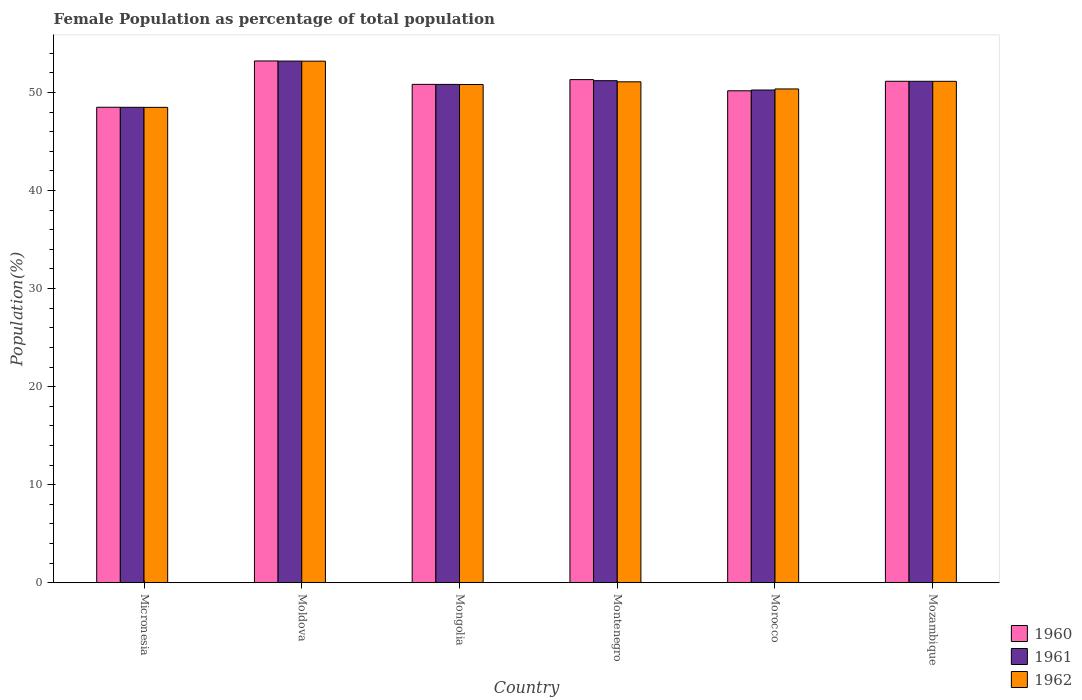How many groups of bars are there?
Give a very brief answer. 6. How many bars are there on the 5th tick from the left?
Give a very brief answer. 3. What is the label of the 6th group of bars from the left?
Make the answer very short. Mozambique. In how many cases, is the number of bars for a given country not equal to the number of legend labels?
Give a very brief answer. 0. What is the female population in in 1961 in Moldova?
Make the answer very short. 53.2. Across all countries, what is the maximum female population in in 1961?
Ensure brevity in your answer.  53.2. Across all countries, what is the minimum female population in in 1960?
Your response must be concise. 48.49. In which country was the female population in in 1961 maximum?
Your answer should be compact. Moldova. In which country was the female population in in 1960 minimum?
Offer a very short reply. Micronesia. What is the total female population in in 1962 in the graph?
Make the answer very short. 305.08. What is the difference between the female population in in 1962 in Mongolia and that in Morocco?
Provide a short and direct response. 0.45. What is the difference between the female population in in 1960 in Moldova and the female population in in 1962 in Mongolia?
Offer a very short reply. 2.4. What is the average female population in in 1960 per country?
Provide a succinct answer. 50.86. What is the difference between the female population in of/in 1960 and female population in of/in 1961 in Mozambique?
Make the answer very short. 0. In how many countries, is the female population in in 1962 greater than 24 %?
Provide a succinct answer. 6. What is the ratio of the female population in in 1962 in Micronesia to that in Montenegro?
Make the answer very short. 0.95. Is the female population in in 1960 in Micronesia less than that in Mongolia?
Your response must be concise. Yes. What is the difference between the highest and the second highest female population in in 1961?
Ensure brevity in your answer.  -0.06. What is the difference between the highest and the lowest female population in in 1960?
Offer a very short reply. 4.72. Is the sum of the female population in in 1962 in Mongolia and Montenegro greater than the maximum female population in in 1961 across all countries?
Offer a very short reply. Yes. How many bars are there?
Offer a very short reply. 18. Are all the bars in the graph horizontal?
Provide a short and direct response. No. How many countries are there in the graph?
Your response must be concise. 6. What is the difference between two consecutive major ticks on the Y-axis?
Ensure brevity in your answer.  10. Does the graph contain grids?
Give a very brief answer. No. Where does the legend appear in the graph?
Ensure brevity in your answer.  Bottom right. How many legend labels are there?
Offer a very short reply. 3. What is the title of the graph?
Give a very brief answer. Female Population as percentage of total population. Does "2013" appear as one of the legend labels in the graph?
Your response must be concise. No. What is the label or title of the X-axis?
Ensure brevity in your answer.  Country. What is the label or title of the Y-axis?
Provide a short and direct response. Population(%). What is the Population(%) of 1960 in Micronesia?
Your answer should be compact. 48.49. What is the Population(%) in 1961 in Micronesia?
Give a very brief answer. 48.49. What is the Population(%) in 1962 in Micronesia?
Provide a succinct answer. 48.48. What is the Population(%) of 1960 in Moldova?
Make the answer very short. 53.21. What is the Population(%) of 1961 in Moldova?
Your answer should be very brief. 53.2. What is the Population(%) in 1962 in Moldova?
Provide a succinct answer. 53.19. What is the Population(%) in 1960 in Mongolia?
Provide a succinct answer. 50.83. What is the Population(%) of 1961 in Mongolia?
Your answer should be very brief. 50.82. What is the Population(%) of 1962 in Mongolia?
Provide a succinct answer. 50.82. What is the Population(%) in 1960 in Montenegro?
Provide a short and direct response. 51.31. What is the Population(%) of 1961 in Montenegro?
Give a very brief answer. 51.2. What is the Population(%) of 1962 in Montenegro?
Keep it short and to the point. 51.09. What is the Population(%) of 1960 in Morocco?
Provide a succinct answer. 50.17. What is the Population(%) of 1961 in Morocco?
Keep it short and to the point. 50.25. What is the Population(%) of 1962 in Morocco?
Your answer should be compact. 50.36. What is the Population(%) of 1960 in Mozambique?
Offer a terse response. 51.14. What is the Population(%) of 1961 in Mozambique?
Your answer should be very brief. 51.14. What is the Population(%) of 1962 in Mozambique?
Keep it short and to the point. 51.14. Across all countries, what is the maximum Population(%) in 1960?
Make the answer very short. 53.21. Across all countries, what is the maximum Population(%) of 1961?
Provide a succinct answer. 53.2. Across all countries, what is the maximum Population(%) of 1962?
Your answer should be compact. 53.19. Across all countries, what is the minimum Population(%) in 1960?
Your answer should be very brief. 48.49. Across all countries, what is the minimum Population(%) of 1961?
Your answer should be very brief. 48.49. Across all countries, what is the minimum Population(%) of 1962?
Your answer should be compact. 48.48. What is the total Population(%) of 1960 in the graph?
Provide a succinct answer. 305.17. What is the total Population(%) in 1961 in the graph?
Your response must be concise. 305.11. What is the total Population(%) in 1962 in the graph?
Your answer should be compact. 305.08. What is the difference between the Population(%) in 1960 in Micronesia and that in Moldova?
Offer a very short reply. -4.72. What is the difference between the Population(%) of 1961 in Micronesia and that in Moldova?
Provide a succinct answer. -4.72. What is the difference between the Population(%) in 1962 in Micronesia and that in Moldova?
Offer a terse response. -4.71. What is the difference between the Population(%) in 1960 in Micronesia and that in Mongolia?
Your response must be concise. -2.34. What is the difference between the Population(%) in 1961 in Micronesia and that in Mongolia?
Your response must be concise. -2.34. What is the difference between the Population(%) of 1962 in Micronesia and that in Mongolia?
Your answer should be compact. -2.33. What is the difference between the Population(%) of 1960 in Micronesia and that in Montenegro?
Ensure brevity in your answer.  -2.82. What is the difference between the Population(%) of 1961 in Micronesia and that in Montenegro?
Give a very brief answer. -2.72. What is the difference between the Population(%) of 1962 in Micronesia and that in Montenegro?
Your response must be concise. -2.61. What is the difference between the Population(%) in 1960 in Micronesia and that in Morocco?
Your answer should be compact. -1.68. What is the difference between the Population(%) in 1961 in Micronesia and that in Morocco?
Your response must be concise. -1.76. What is the difference between the Population(%) of 1962 in Micronesia and that in Morocco?
Your response must be concise. -1.88. What is the difference between the Population(%) in 1960 in Micronesia and that in Mozambique?
Your answer should be very brief. -2.65. What is the difference between the Population(%) in 1961 in Micronesia and that in Mozambique?
Keep it short and to the point. -2.65. What is the difference between the Population(%) of 1962 in Micronesia and that in Mozambique?
Offer a very short reply. -2.66. What is the difference between the Population(%) in 1960 in Moldova and that in Mongolia?
Provide a short and direct response. 2.39. What is the difference between the Population(%) in 1961 in Moldova and that in Mongolia?
Ensure brevity in your answer.  2.38. What is the difference between the Population(%) in 1962 in Moldova and that in Mongolia?
Provide a succinct answer. 2.38. What is the difference between the Population(%) of 1960 in Moldova and that in Montenegro?
Your answer should be very brief. 1.9. What is the difference between the Population(%) of 1961 in Moldova and that in Montenegro?
Give a very brief answer. 2. What is the difference between the Population(%) of 1962 in Moldova and that in Montenegro?
Your response must be concise. 2.1. What is the difference between the Population(%) in 1960 in Moldova and that in Morocco?
Your response must be concise. 3.04. What is the difference between the Population(%) in 1961 in Moldova and that in Morocco?
Your response must be concise. 2.95. What is the difference between the Population(%) in 1962 in Moldova and that in Morocco?
Your answer should be very brief. 2.83. What is the difference between the Population(%) of 1960 in Moldova and that in Mozambique?
Keep it short and to the point. 2.07. What is the difference between the Population(%) in 1961 in Moldova and that in Mozambique?
Ensure brevity in your answer.  2.06. What is the difference between the Population(%) in 1962 in Moldova and that in Mozambique?
Make the answer very short. 2.06. What is the difference between the Population(%) of 1960 in Mongolia and that in Montenegro?
Your response must be concise. -0.49. What is the difference between the Population(%) of 1961 in Mongolia and that in Montenegro?
Provide a succinct answer. -0.38. What is the difference between the Population(%) in 1962 in Mongolia and that in Montenegro?
Make the answer very short. -0.27. What is the difference between the Population(%) of 1960 in Mongolia and that in Morocco?
Provide a short and direct response. 0.65. What is the difference between the Population(%) of 1961 in Mongolia and that in Morocco?
Keep it short and to the point. 0.57. What is the difference between the Population(%) in 1962 in Mongolia and that in Morocco?
Offer a very short reply. 0.45. What is the difference between the Population(%) of 1960 in Mongolia and that in Mozambique?
Ensure brevity in your answer.  -0.32. What is the difference between the Population(%) of 1961 in Mongolia and that in Mozambique?
Ensure brevity in your answer.  -0.32. What is the difference between the Population(%) in 1962 in Mongolia and that in Mozambique?
Your answer should be compact. -0.32. What is the difference between the Population(%) in 1960 in Montenegro and that in Morocco?
Provide a succinct answer. 1.14. What is the difference between the Population(%) in 1961 in Montenegro and that in Morocco?
Your answer should be compact. 0.95. What is the difference between the Population(%) of 1962 in Montenegro and that in Morocco?
Your response must be concise. 0.73. What is the difference between the Population(%) of 1960 in Montenegro and that in Mozambique?
Offer a very short reply. 0.17. What is the difference between the Population(%) of 1961 in Montenegro and that in Mozambique?
Offer a very short reply. 0.06. What is the difference between the Population(%) of 1962 in Montenegro and that in Mozambique?
Keep it short and to the point. -0.05. What is the difference between the Population(%) in 1960 in Morocco and that in Mozambique?
Your answer should be compact. -0.97. What is the difference between the Population(%) of 1961 in Morocco and that in Mozambique?
Your answer should be compact. -0.89. What is the difference between the Population(%) of 1962 in Morocco and that in Mozambique?
Ensure brevity in your answer.  -0.78. What is the difference between the Population(%) in 1960 in Micronesia and the Population(%) in 1961 in Moldova?
Your answer should be compact. -4.71. What is the difference between the Population(%) of 1960 in Micronesia and the Population(%) of 1962 in Moldova?
Offer a very short reply. -4.7. What is the difference between the Population(%) in 1961 in Micronesia and the Population(%) in 1962 in Moldova?
Make the answer very short. -4.71. What is the difference between the Population(%) of 1960 in Micronesia and the Population(%) of 1961 in Mongolia?
Make the answer very short. -2.33. What is the difference between the Population(%) of 1960 in Micronesia and the Population(%) of 1962 in Mongolia?
Keep it short and to the point. -2.32. What is the difference between the Population(%) of 1961 in Micronesia and the Population(%) of 1962 in Mongolia?
Offer a terse response. -2.33. What is the difference between the Population(%) in 1960 in Micronesia and the Population(%) in 1961 in Montenegro?
Your response must be concise. -2.71. What is the difference between the Population(%) of 1960 in Micronesia and the Population(%) of 1962 in Montenegro?
Your answer should be very brief. -2.6. What is the difference between the Population(%) of 1961 in Micronesia and the Population(%) of 1962 in Montenegro?
Provide a succinct answer. -2.6. What is the difference between the Population(%) of 1960 in Micronesia and the Population(%) of 1961 in Morocco?
Your response must be concise. -1.76. What is the difference between the Population(%) of 1960 in Micronesia and the Population(%) of 1962 in Morocco?
Make the answer very short. -1.87. What is the difference between the Population(%) in 1961 in Micronesia and the Population(%) in 1962 in Morocco?
Your answer should be very brief. -1.87. What is the difference between the Population(%) in 1960 in Micronesia and the Population(%) in 1961 in Mozambique?
Ensure brevity in your answer.  -2.65. What is the difference between the Population(%) of 1960 in Micronesia and the Population(%) of 1962 in Mozambique?
Offer a terse response. -2.65. What is the difference between the Population(%) of 1961 in Micronesia and the Population(%) of 1962 in Mozambique?
Keep it short and to the point. -2.65. What is the difference between the Population(%) in 1960 in Moldova and the Population(%) in 1961 in Mongolia?
Give a very brief answer. 2.39. What is the difference between the Population(%) of 1960 in Moldova and the Population(%) of 1962 in Mongolia?
Ensure brevity in your answer.  2.4. What is the difference between the Population(%) of 1961 in Moldova and the Population(%) of 1962 in Mongolia?
Give a very brief answer. 2.39. What is the difference between the Population(%) in 1960 in Moldova and the Population(%) in 1961 in Montenegro?
Make the answer very short. 2.01. What is the difference between the Population(%) in 1960 in Moldova and the Population(%) in 1962 in Montenegro?
Offer a terse response. 2.13. What is the difference between the Population(%) of 1961 in Moldova and the Population(%) of 1962 in Montenegro?
Keep it short and to the point. 2.11. What is the difference between the Population(%) in 1960 in Moldova and the Population(%) in 1961 in Morocco?
Make the answer very short. 2.96. What is the difference between the Population(%) of 1960 in Moldova and the Population(%) of 1962 in Morocco?
Your response must be concise. 2.85. What is the difference between the Population(%) in 1961 in Moldova and the Population(%) in 1962 in Morocco?
Your response must be concise. 2.84. What is the difference between the Population(%) of 1960 in Moldova and the Population(%) of 1961 in Mozambique?
Give a very brief answer. 2.07. What is the difference between the Population(%) of 1960 in Moldova and the Population(%) of 1962 in Mozambique?
Make the answer very short. 2.08. What is the difference between the Population(%) of 1961 in Moldova and the Population(%) of 1962 in Mozambique?
Keep it short and to the point. 2.06. What is the difference between the Population(%) of 1960 in Mongolia and the Population(%) of 1961 in Montenegro?
Your response must be concise. -0.38. What is the difference between the Population(%) of 1960 in Mongolia and the Population(%) of 1962 in Montenegro?
Your response must be concise. -0.26. What is the difference between the Population(%) in 1961 in Mongolia and the Population(%) in 1962 in Montenegro?
Ensure brevity in your answer.  -0.27. What is the difference between the Population(%) of 1960 in Mongolia and the Population(%) of 1961 in Morocco?
Offer a very short reply. 0.58. What is the difference between the Population(%) in 1960 in Mongolia and the Population(%) in 1962 in Morocco?
Keep it short and to the point. 0.47. What is the difference between the Population(%) of 1961 in Mongolia and the Population(%) of 1962 in Morocco?
Keep it short and to the point. 0.46. What is the difference between the Population(%) of 1960 in Mongolia and the Population(%) of 1961 in Mozambique?
Your answer should be very brief. -0.31. What is the difference between the Population(%) in 1960 in Mongolia and the Population(%) in 1962 in Mozambique?
Your response must be concise. -0.31. What is the difference between the Population(%) in 1961 in Mongolia and the Population(%) in 1962 in Mozambique?
Keep it short and to the point. -0.31. What is the difference between the Population(%) in 1960 in Montenegro and the Population(%) in 1961 in Morocco?
Offer a terse response. 1.06. What is the difference between the Population(%) in 1960 in Montenegro and the Population(%) in 1962 in Morocco?
Provide a succinct answer. 0.95. What is the difference between the Population(%) of 1961 in Montenegro and the Population(%) of 1962 in Morocco?
Provide a succinct answer. 0.84. What is the difference between the Population(%) in 1960 in Montenegro and the Population(%) in 1961 in Mozambique?
Your answer should be compact. 0.17. What is the difference between the Population(%) of 1960 in Montenegro and the Population(%) of 1962 in Mozambique?
Your response must be concise. 0.17. What is the difference between the Population(%) of 1961 in Montenegro and the Population(%) of 1962 in Mozambique?
Ensure brevity in your answer.  0.07. What is the difference between the Population(%) of 1960 in Morocco and the Population(%) of 1961 in Mozambique?
Your answer should be compact. -0.97. What is the difference between the Population(%) of 1960 in Morocco and the Population(%) of 1962 in Mozambique?
Offer a terse response. -0.97. What is the difference between the Population(%) of 1961 in Morocco and the Population(%) of 1962 in Mozambique?
Offer a terse response. -0.89. What is the average Population(%) in 1960 per country?
Give a very brief answer. 50.86. What is the average Population(%) of 1961 per country?
Your response must be concise. 50.85. What is the average Population(%) of 1962 per country?
Ensure brevity in your answer.  50.85. What is the difference between the Population(%) in 1960 and Population(%) in 1961 in Micronesia?
Your answer should be very brief. 0. What is the difference between the Population(%) in 1960 and Population(%) in 1962 in Micronesia?
Your answer should be very brief. 0.01. What is the difference between the Population(%) of 1961 and Population(%) of 1962 in Micronesia?
Your answer should be compact. 0.01. What is the difference between the Population(%) in 1960 and Population(%) in 1961 in Moldova?
Give a very brief answer. 0.01. What is the difference between the Population(%) in 1960 and Population(%) in 1962 in Moldova?
Offer a terse response. 0.02. What is the difference between the Population(%) in 1961 and Population(%) in 1962 in Moldova?
Make the answer very short. 0.01. What is the difference between the Population(%) in 1960 and Population(%) in 1961 in Mongolia?
Make the answer very short. 0. What is the difference between the Population(%) of 1960 and Population(%) of 1962 in Mongolia?
Your response must be concise. 0.01. What is the difference between the Population(%) in 1961 and Population(%) in 1962 in Mongolia?
Give a very brief answer. 0.01. What is the difference between the Population(%) in 1960 and Population(%) in 1961 in Montenegro?
Give a very brief answer. 0.11. What is the difference between the Population(%) in 1960 and Population(%) in 1962 in Montenegro?
Offer a terse response. 0.22. What is the difference between the Population(%) in 1961 and Population(%) in 1962 in Montenegro?
Offer a terse response. 0.11. What is the difference between the Population(%) in 1960 and Population(%) in 1961 in Morocco?
Your answer should be very brief. -0.08. What is the difference between the Population(%) in 1960 and Population(%) in 1962 in Morocco?
Offer a very short reply. -0.19. What is the difference between the Population(%) of 1961 and Population(%) of 1962 in Morocco?
Ensure brevity in your answer.  -0.11. What is the difference between the Population(%) in 1960 and Population(%) in 1961 in Mozambique?
Offer a very short reply. 0. What is the difference between the Population(%) of 1960 and Population(%) of 1962 in Mozambique?
Make the answer very short. 0.01. What is the difference between the Population(%) of 1961 and Population(%) of 1962 in Mozambique?
Ensure brevity in your answer.  0. What is the ratio of the Population(%) in 1960 in Micronesia to that in Moldova?
Offer a very short reply. 0.91. What is the ratio of the Population(%) of 1961 in Micronesia to that in Moldova?
Ensure brevity in your answer.  0.91. What is the ratio of the Population(%) of 1962 in Micronesia to that in Moldova?
Your answer should be very brief. 0.91. What is the ratio of the Population(%) in 1960 in Micronesia to that in Mongolia?
Offer a very short reply. 0.95. What is the ratio of the Population(%) in 1961 in Micronesia to that in Mongolia?
Provide a succinct answer. 0.95. What is the ratio of the Population(%) in 1962 in Micronesia to that in Mongolia?
Offer a very short reply. 0.95. What is the ratio of the Population(%) in 1960 in Micronesia to that in Montenegro?
Your answer should be compact. 0.94. What is the ratio of the Population(%) in 1961 in Micronesia to that in Montenegro?
Offer a very short reply. 0.95. What is the ratio of the Population(%) of 1962 in Micronesia to that in Montenegro?
Your response must be concise. 0.95. What is the ratio of the Population(%) of 1960 in Micronesia to that in Morocco?
Your answer should be compact. 0.97. What is the ratio of the Population(%) in 1961 in Micronesia to that in Morocco?
Your answer should be very brief. 0.96. What is the ratio of the Population(%) of 1962 in Micronesia to that in Morocco?
Make the answer very short. 0.96. What is the ratio of the Population(%) of 1960 in Micronesia to that in Mozambique?
Your response must be concise. 0.95. What is the ratio of the Population(%) in 1961 in Micronesia to that in Mozambique?
Keep it short and to the point. 0.95. What is the ratio of the Population(%) of 1962 in Micronesia to that in Mozambique?
Your answer should be compact. 0.95. What is the ratio of the Population(%) of 1960 in Moldova to that in Mongolia?
Provide a succinct answer. 1.05. What is the ratio of the Population(%) of 1961 in Moldova to that in Mongolia?
Make the answer very short. 1.05. What is the ratio of the Population(%) of 1962 in Moldova to that in Mongolia?
Your answer should be compact. 1.05. What is the ratio of the Population(%) of 1960 in Moldova to that in Montenegro?
Provide a short and direct response. 1.04. What is the ratio of the Population(%) in 1961 in Moldova to that in Montenegro?
Offer a terse response. 1.04. What is the ratio of the Population(%) in 1962 in Moldova to that in Montenegro?
Offer a very short reply. 1.04. What is the ratio of the Population(%) in 1960 in Moldova to that in Morocco?
Offer a terse response. 1.06. What is the ratio of the Population(%) in 1961 in Moldova to that in Morocco?
Give a very brief answer. 1.06. What is the ratio of the Population(%) in 1962 in Moldova to that in Morocco?
Make the answer very short. 1.06. What is the ratio of the Population(%) in 1960 in Moldova to that in Mozambique?
Provide a succinct answer. 1.04. What is the ratio of the Population(%) in 1961 in Moldova to that in Mozambique?
Make the answer very short. 1.04. What is the ratio of the Population(%) of 1962 in Moldova to that in Mozambique?
Your answer should be very brief. 1.04. What is the ratio of the Population(%) of 1961 in Mongolia to that in Montenegro?
Offer a very short reply. 0.99. What is the ratio of the Population(%) of 1962 in Mongolia to that in Montenegro?
Ensure brevity in your answer.  0.99. What is the ratio of the Population(%) in 1960 in Mongolia to that in Morocco?
Provide a succinct answer. 1.01. What is the ratio of the Population(%) in 1961 in Mongolia to that in Morocco?
Keep it short and to the point. 1.01. What is the ratio of the Population(%) of 1961 in Mongolia to that in Mozambique?
Your response must be concise. 0.99. What is the ratio of the Population(%) of 1962 in Mongolia to that in Mozambique?
Keep it short and to the point. 0.99. What is the ratio of the Population(%) of 1960 in Montenegro to that in Morocco?
Give a very brief answer. 1.02. What is the ratio of the Population(%) of 1961 in Montenegro to that in Morocco?
Provide a succinct answer. 1.02. What is the ratio of the Population(%) in 1962 in Montenegro to that in Morocco?
Your answer should be compact. 1.01. What is the ratio of the Population(%) of 1961 in Montenegro to that in Mozambique?
Provide a succinct answer. 1. What is the ratio of the Population(%) in 1962 in Montenegro to that in Mozambique?
Provide a short and direct response. 1. What is the ratio of the Population(%) in 1961 in Morocco to that in Mozambique?
Your answer should be compact. 0.98. What is the difference between the highest and the second highest Population(%) in 1960?
Your answer should be compact. 1.9. What is the difference between the highest and the second highest Population(%) in 1961?
Provide a short and direct response. 2. What is the difference between the highest and the second highest Population(%) in 1962?
Provide a succinct answer. 2.06. What is the difference between the highest and the lowest Population(%) in 1960?
Provide a succinct answer. 4.72. What is the difference between the highest and the lowest Population(%) of 1961?
Provide a short and direct response. 4.72. What is the difference between the highest and the lowest Population(%) in 1962?
Your answer should be compact. 4.71. 